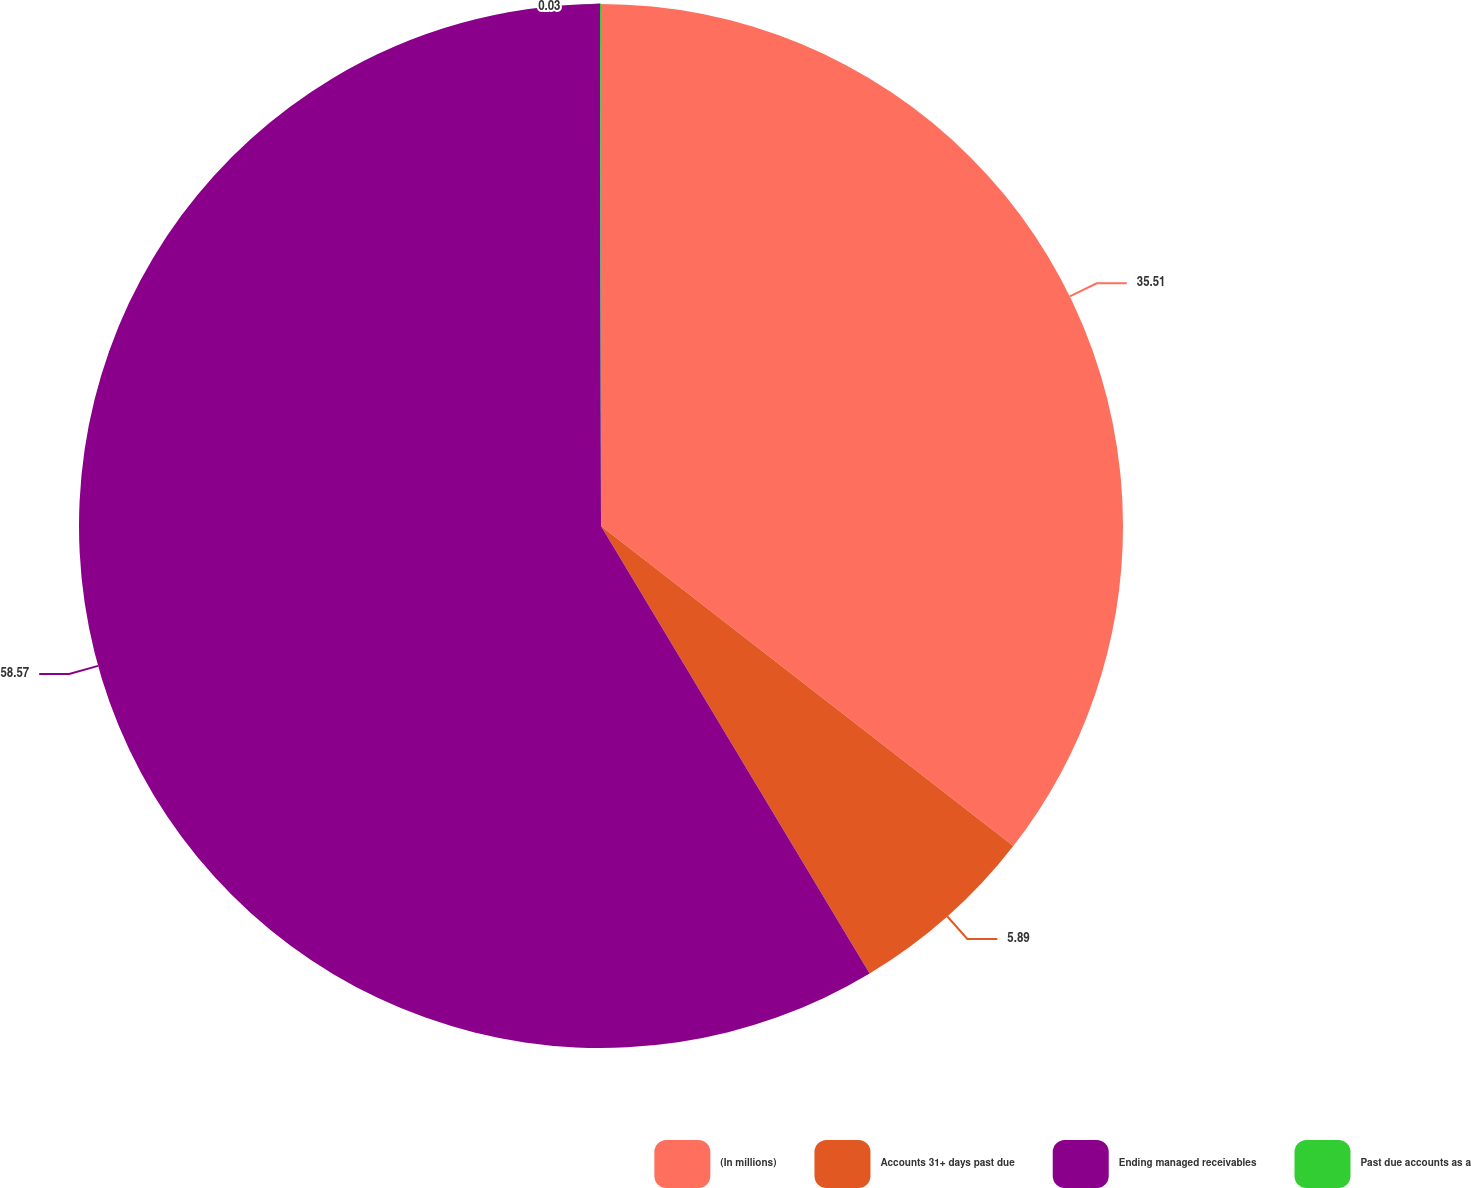Convert chart. <chart><loc_0><loc_0><loc_500><loc_500><pie_chart><fcel>(In millions)<fcel>Accounts 31+ days past due<fcel>Ending managed receivables<fcel>Past due accounts as a<nl><fcel>35.51%<fcel>5.89%<fcel>58.58%<fcel>0.03%<nl></chart> 